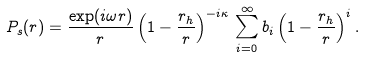Convert formula to latex. <formula><loc_0><loc_0><loc_500><loc_500>P _ { s } ( r ) = \frac { \exp ( i \omega r ) } { r } \left ( 1 - \frac { r _ { h } } { r } \right ) ^ { - i \kappa } \, \sum _ { i = 0 } ^ { \infty } b _ { i } \left ( 1 - \frac { r _ { h } } { r } \right ) ^ { i } .</formula> 